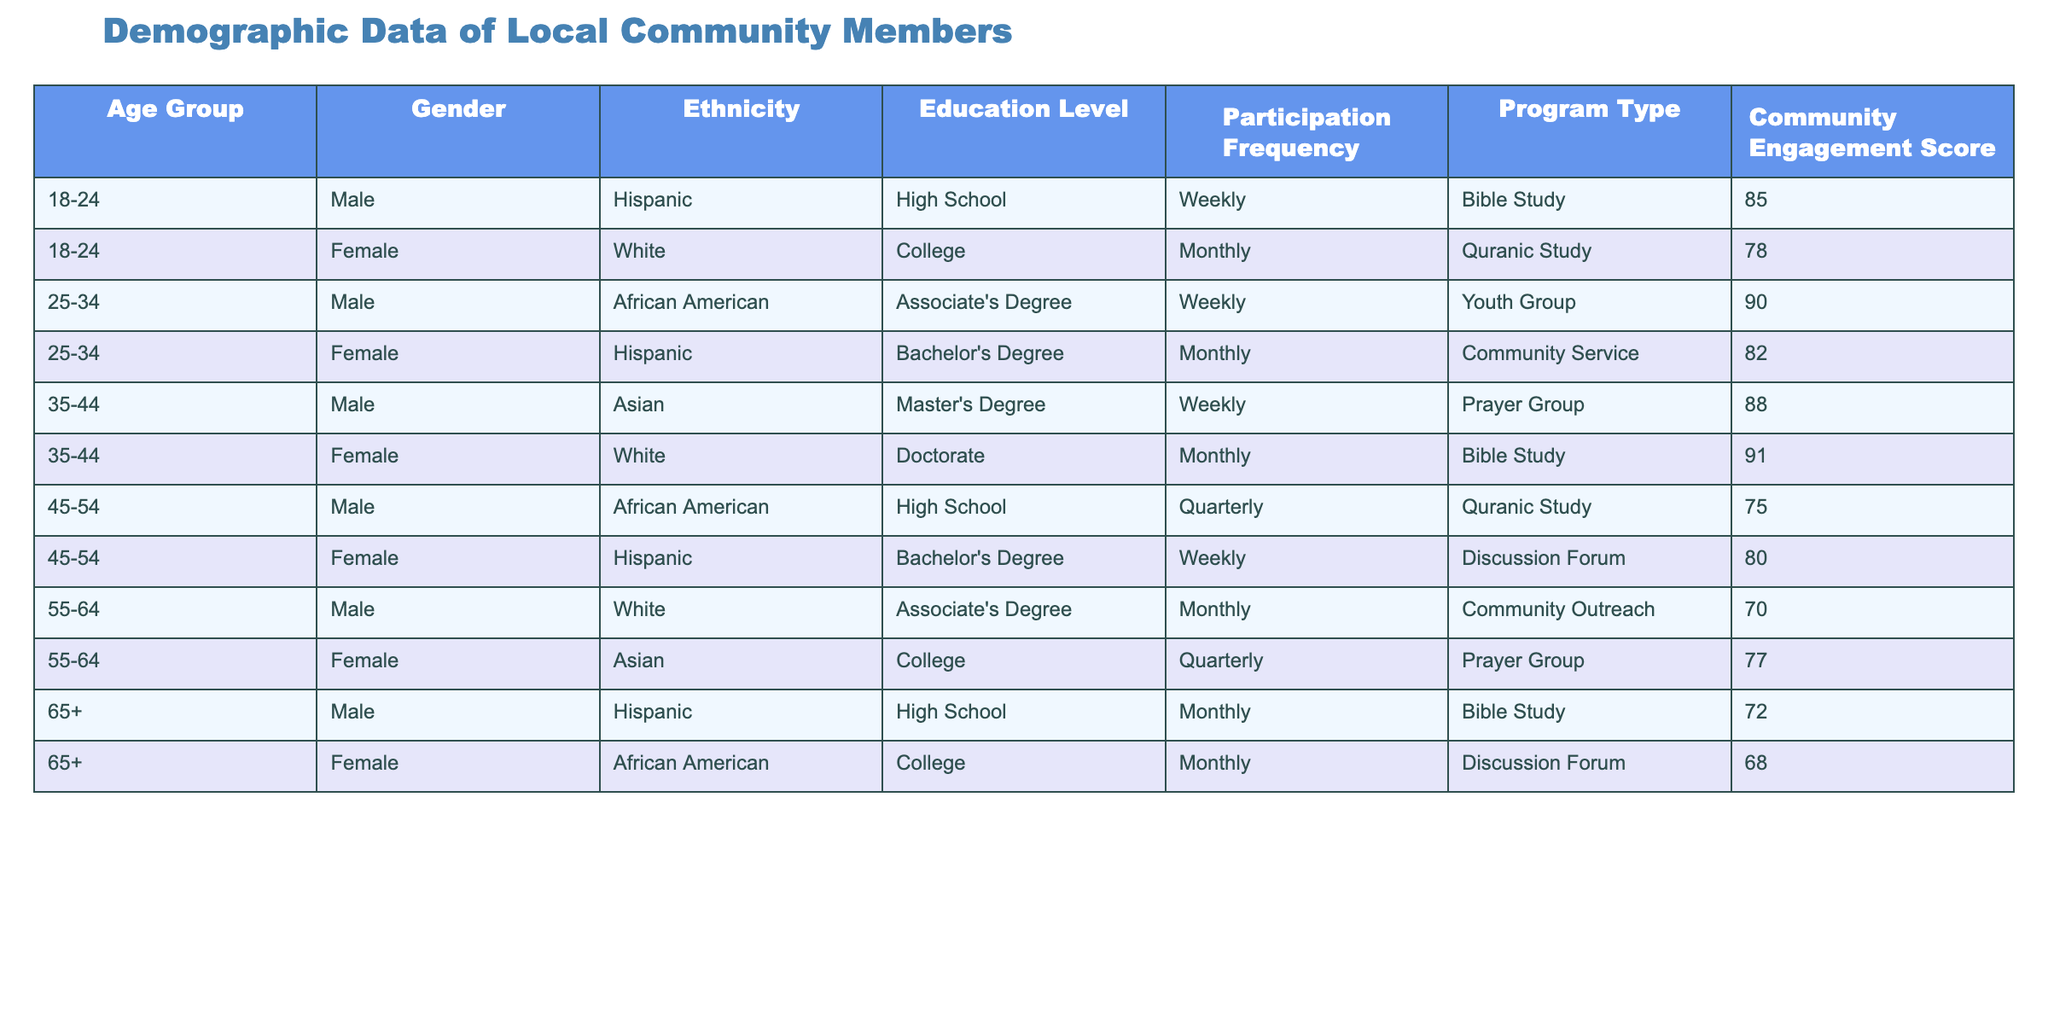What is the community engagement score for females aged 65 and older? Referring to the table, we find the row for females in the age group of 65+. The engagement score listed there is 68.
Answer: 68 What is the most common education level among males aged 45-54? Looking at the table, we see that the only education level listed for males aged 45-54 is High School.
Answer: High School How many males participate in the Bible Study program weekly? The table shows two males who participate in Bible Study on a weekly basis: one in the age group 18-24 and another in 35-44. Therefore, there are 2 males.
Answer: 2 What is the average community engagement score for all participants in the Quranic Study program? To calculate the average, we identify the two rows for the Quranic Study program: one for males aged 45-54 (75) and another for females aged 18-24 (78). The sum is 75 + 78 = 153, and there are 2 participants. Thus, the average score is 153 / 2 = 76.5.
Answer: 76.5 Do females with a Doctorate degree participate in the Prayer Group? Checking the table, there is no row that indicates a female with a Doctorate is participating in the Prayer Group; instead, a male with a Master’s Degree is in that group. Therefore, the answer is no.
Answer: No How does the participation frequency differ between the 25-34 age group and the 35-44 age group? In the age group of 25-34, there are two frequencies: Weekly (one male) and Monthly (one female). In the 35-44 age group, both participants have a weekly frequency. Therefore, the 25-34 age group has a combined participation frequency of one weekly and one monthly, while the 35-44 age group has only weekly participation.
Answer: 25-34 has varied frequency; 35-44 has only weekly What is the community engagement score for the only female participant in the 55-64 age group? There is one female participant in the 55-64 age group listed in the table, and her community engagement score is 77.
Answer: 77 How many total participants are there aged 18-24? The table lists two participants aged 18-24: one male and one female. Hence, the total number is 2.
Answer: 2 Is there a female participating at the high school education level? Analyzing the table reveals that there is one female with a Bachelor's Degree (45-54 age group) and one male with a High School level education (45-54 age group). Thus, there is no female at the high school level.
Answer: No 